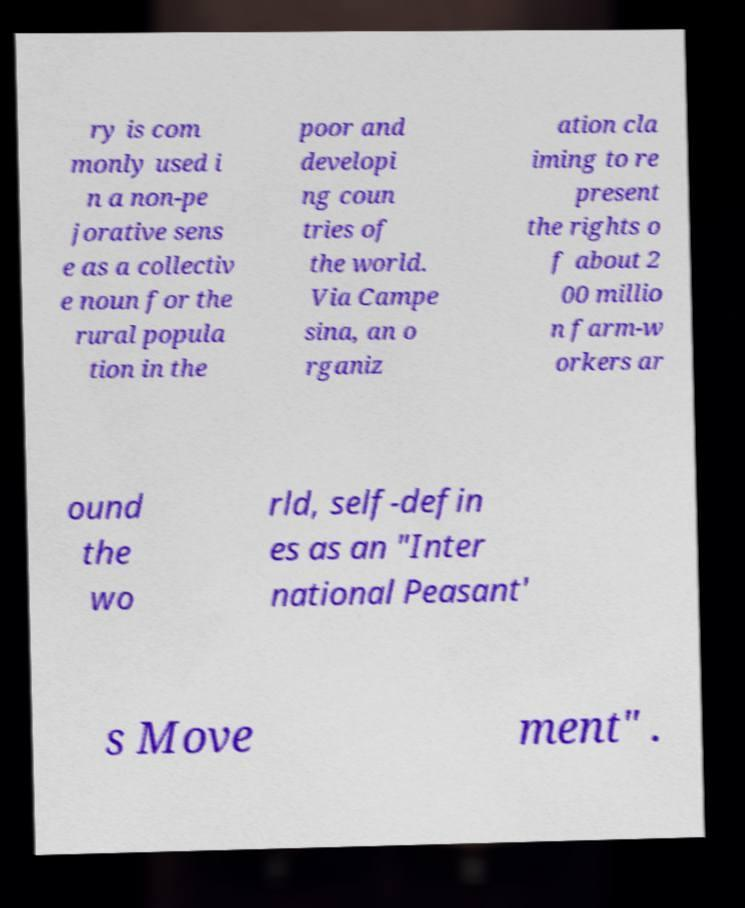Please identify and transcribe the text found in this image. ry is com monly used i n a non-pe jorative sens e as a collectiv e noun for the rural popula tion in the poor and developi ng coun tries of the world. Via Campe sina, an o rganiz ation cla iming to re present the rights o f about 2 00 millio n farm-w orkers ar ound the wo rld, self-defin es as an "Inter national Peasant' s Move ment" . 